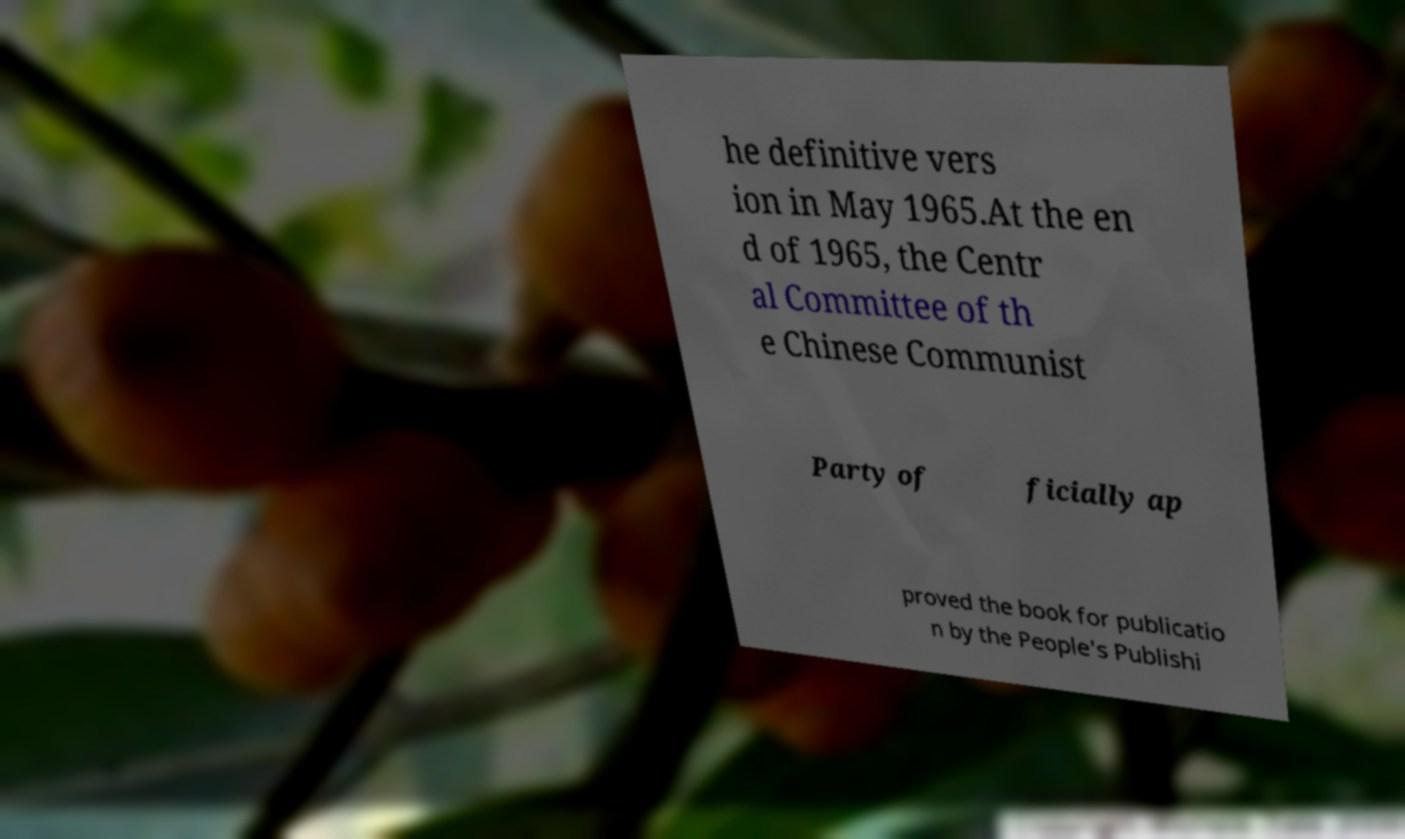I need the written content from this picture converted into text. Can you do that? he definitive vers ion in May 1965.At the en d of 1965, the Centr al Committee of th e Chinese Communist Party of ficially ap proved the book for publicatio n by the People's Publishi 